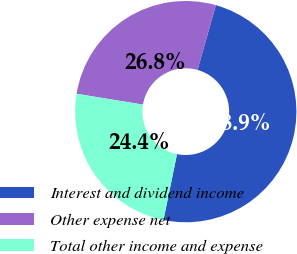Convert chart to OTSL. <chart><loc_0><loc_0><loc_500><loc_500><pie_chart><fcel>Interest and dividend income<fcel>Other expense net<fcel>Total other income and expense<nl><fcel>48.85%<fcel>26.8%<fcel>24.35%<nl></chart> 